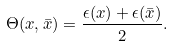<formula> <loc_0><loc_0><loc_500><loc_500>\Theta ( x , \bar { x } ) = \frac { \epsilon ( x ) + \epsilon ( \bar { x } ) } { 2 } .</formula> 